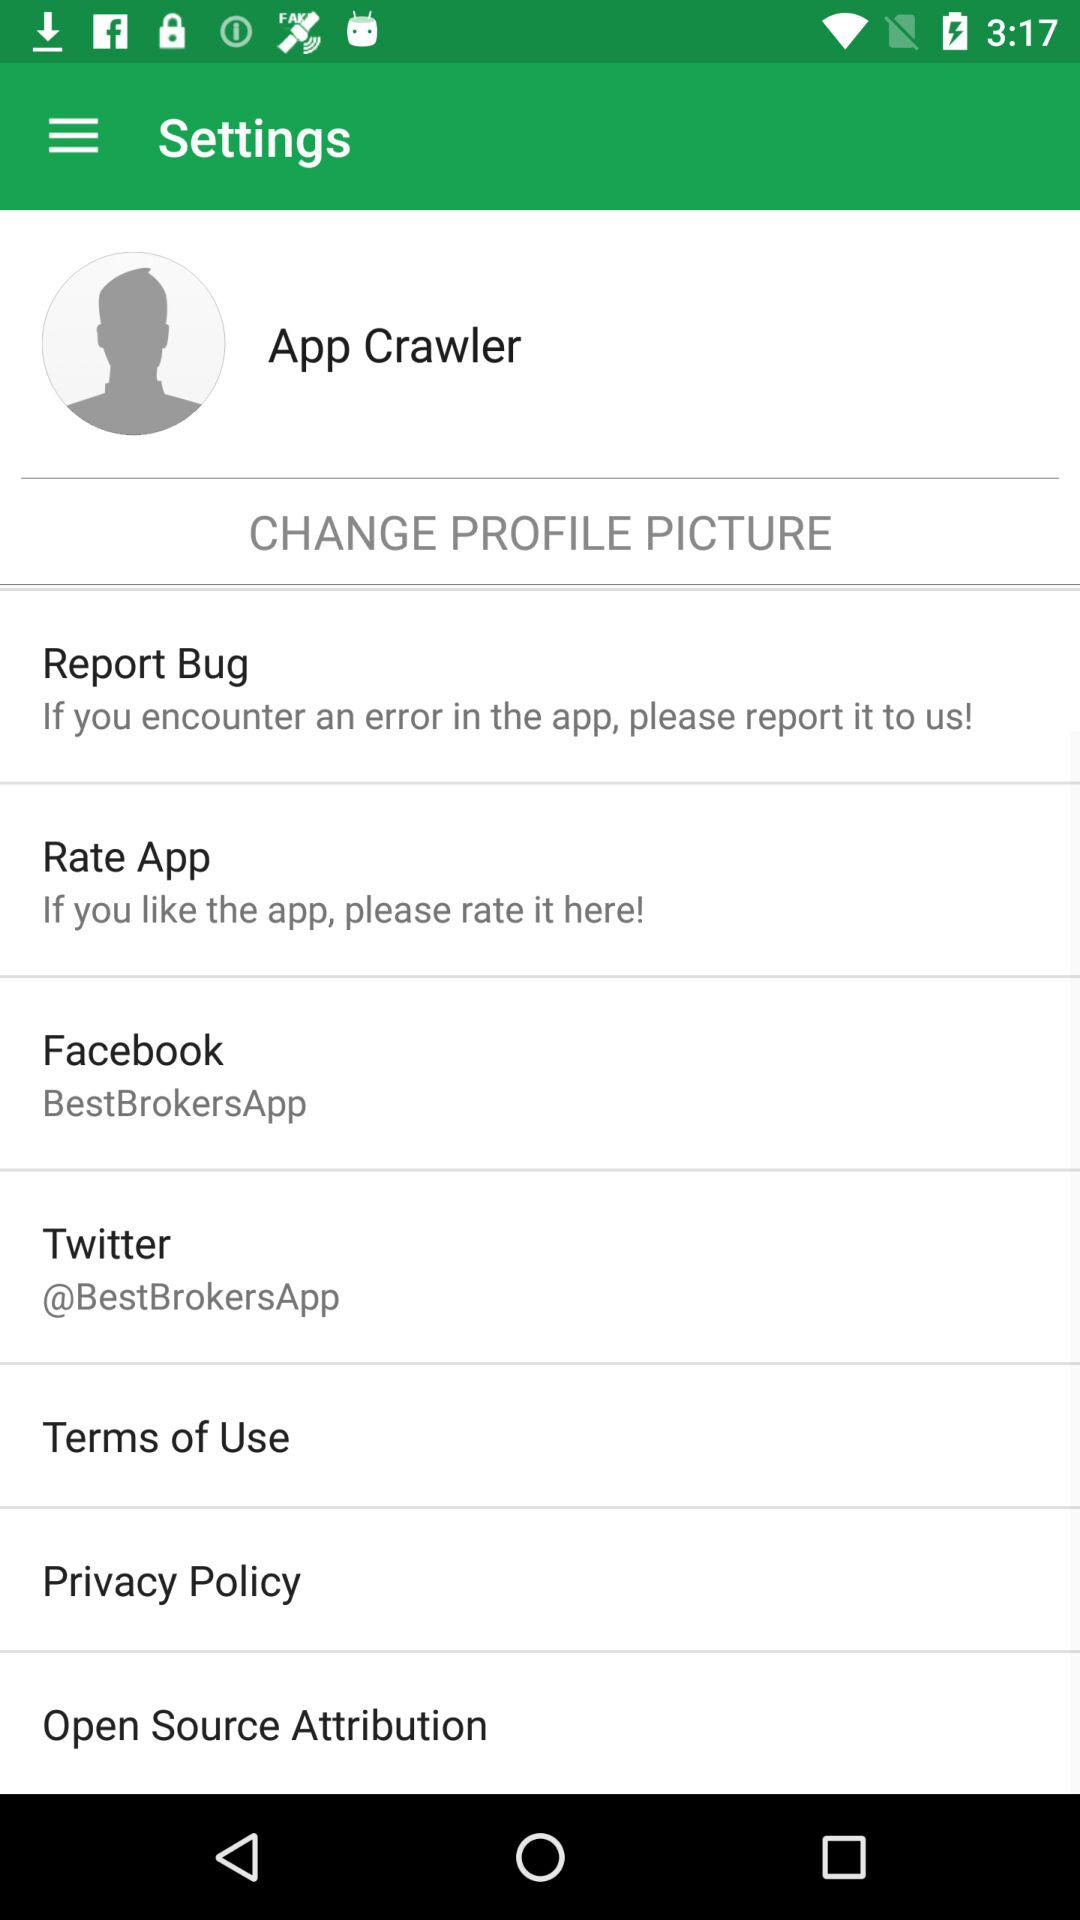What is the user name? The user name is App Crawler. 